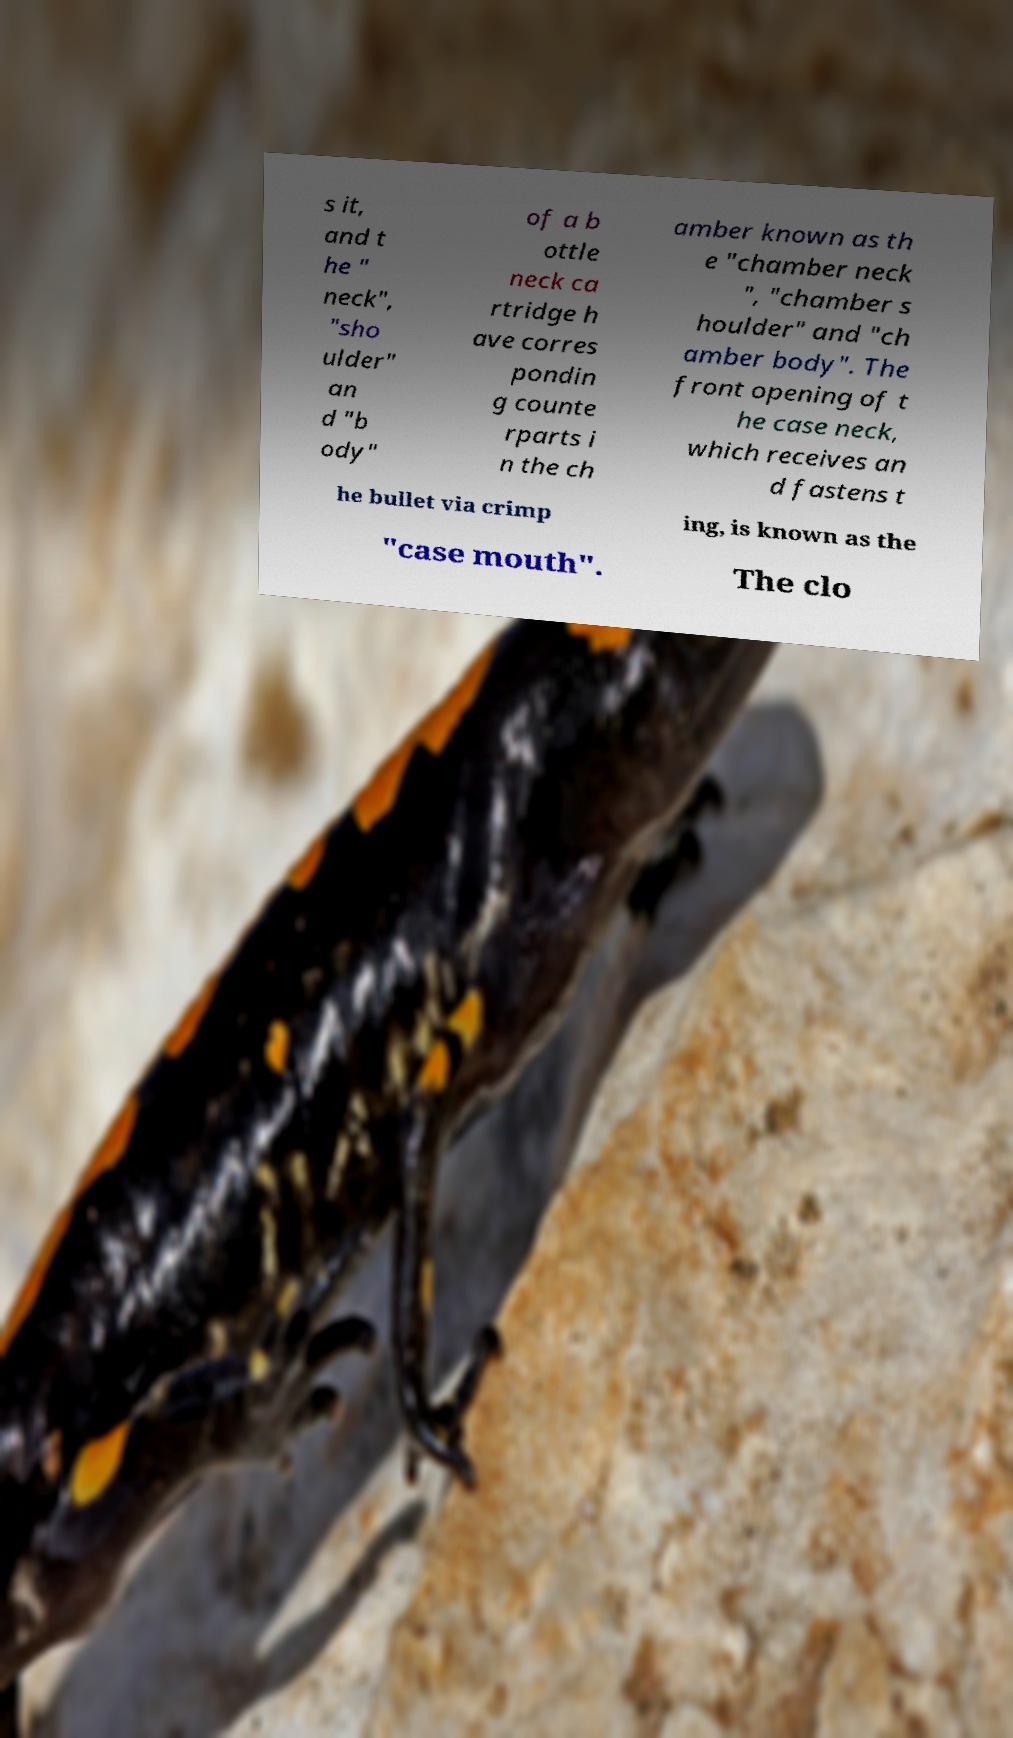I need the written content from this picture converted into text. Can you do that? s it, and t he " neck", "sho ulder" an d "b ody" of a b ottle neck ca rtridge h ave corres pondin g counte rparts i n the ch amber known as th e "chamber neck ", "chamber s houlder" and "ch amber body". The front opening of t he case neck, which receives an d fastens t he bullet via crimp ing, is known as the "case mouth". The clo 